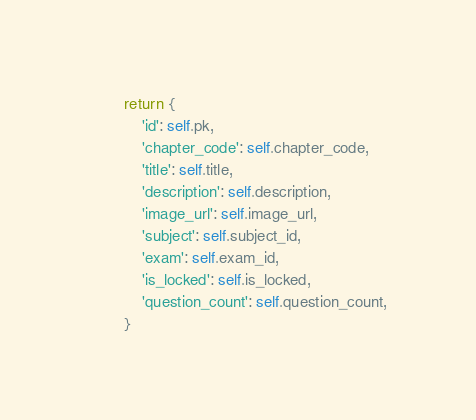<code> <loc_0><loc_0><loc_500><loc_500><_Python_>        return {
            'id': self.pk,
            'chapter_code': self.chapter_code,
            'title': self.title,
            'description': self.description,
            'image_url': self.image_url,
            'subject': self.subject_id,
            'exam': self.exam_id,
            'is_locked': self.is_locked,
            'question_count': self.question_count,
        }
</code> 